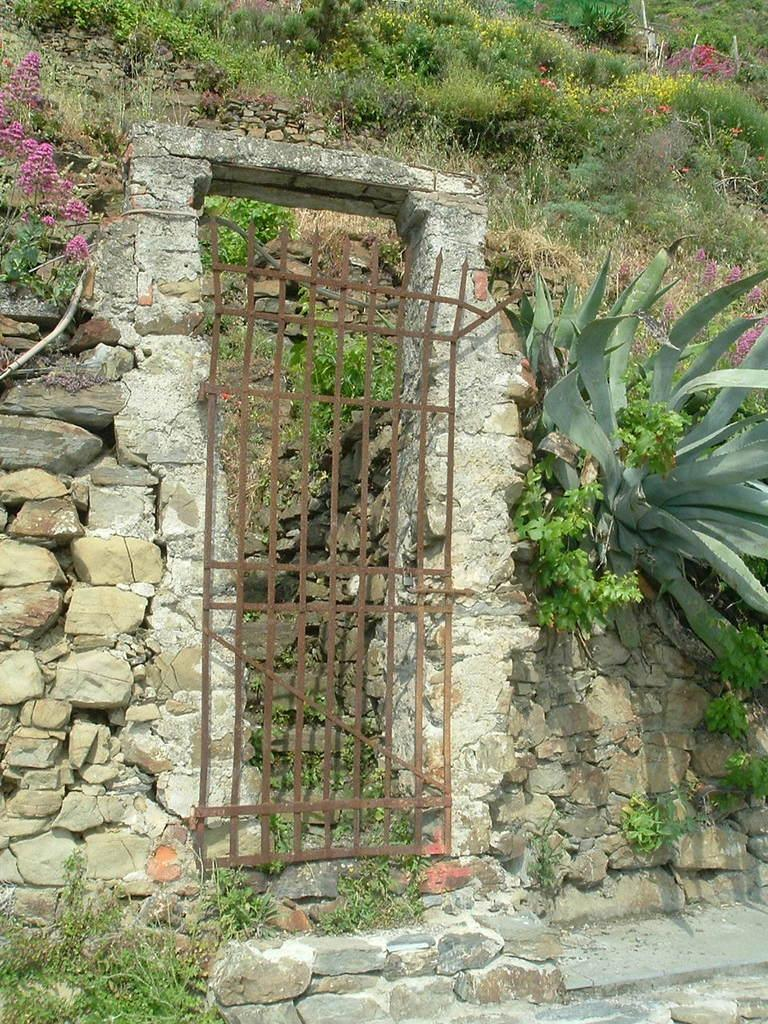What type of living organisms can be seen in the image? Plants can be seen in the image. What type of structure is present in the image? There is a stone wall in the image. What type of material is used for the gate in the image? There is a metal gate in the image. How many cherries are hanging from the plants in the image? There are no cherries present in the image; it features plants, a stone wall, and a metal gate. What type of brass object can be seen in the image? There is no brass object present in the image. 